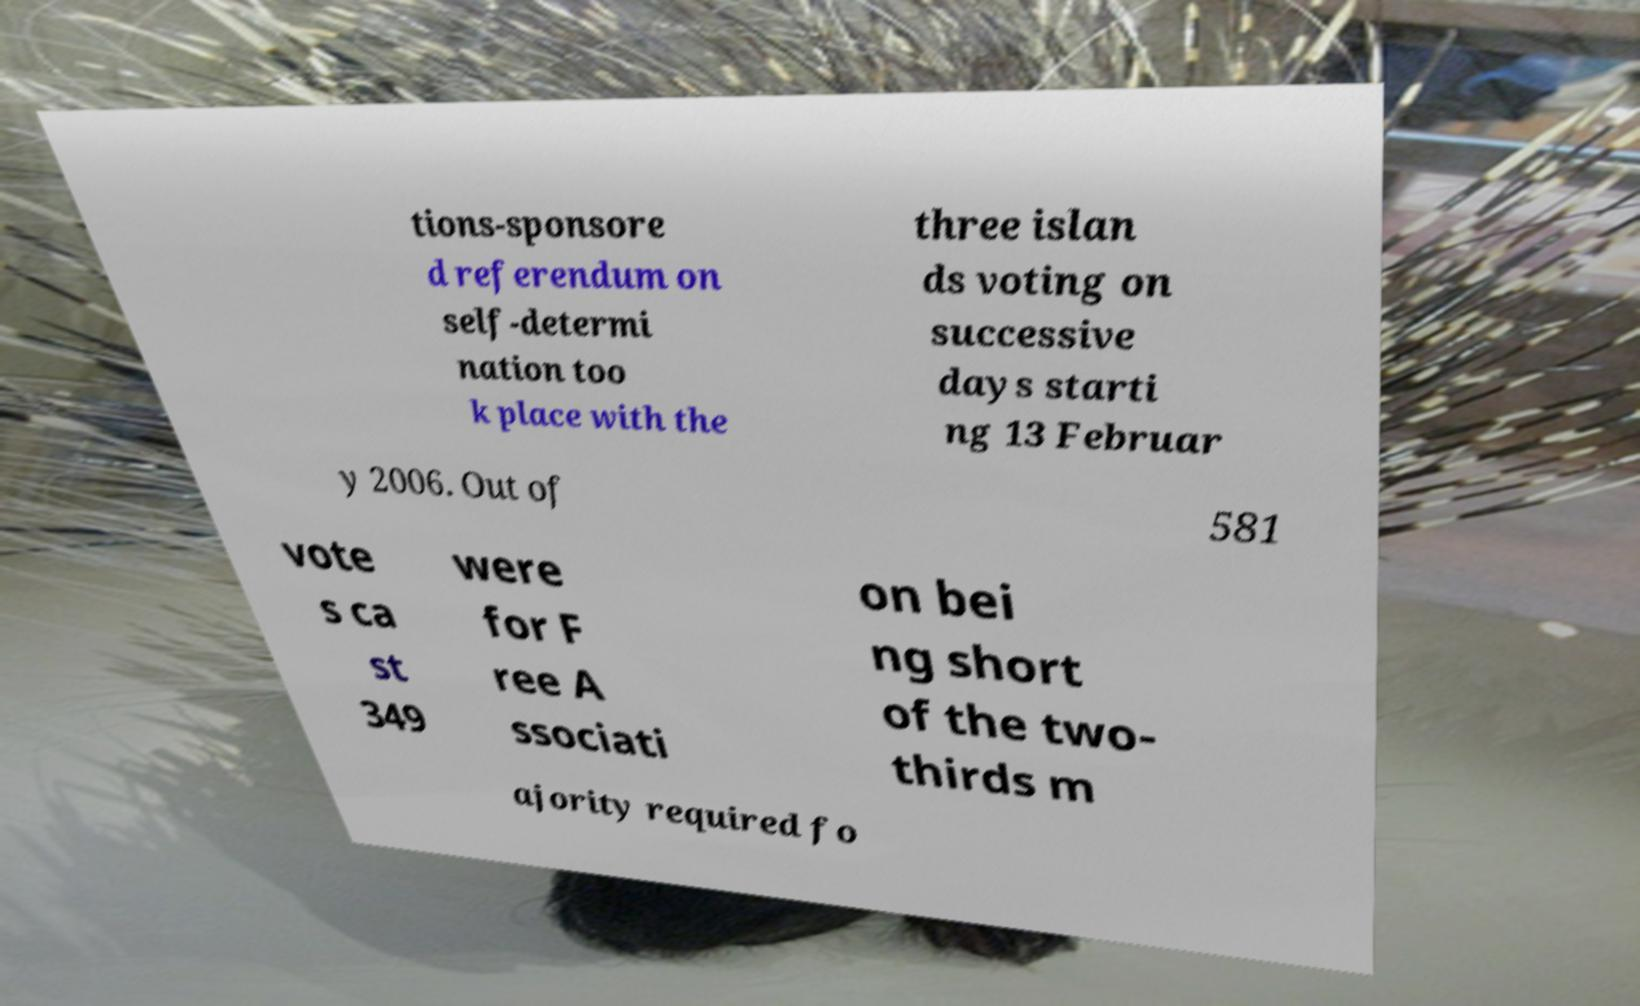Can you read and provide the text displayed in the image?This photo seems to have some interesting text. Can you extract and type it out for me? tions-sponsore d referendum on self-determi nation too k place with the three islan ds voting on successive days starti ng 13 Februar y 2006. Out of 581 vote s ca st 349 were for F ree A ssociati on bei ng short of the two- thirds m ajority required fo 